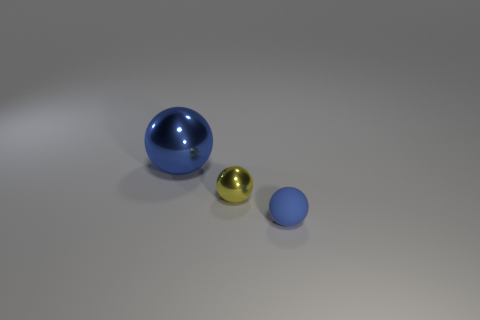Are there any other things that are the same size as the blue metallic object?
Give a very brief answer. No. There is a blue sphere that is right of the blue metallic object; is it the same size as the metal sphere that is right of the large metallic sphere?
Offer a very short reply. Yes. Is there anything else that is the same material as the big ball?
Offer a very short reply. Yes. What number of things are things that are left of the yellow metallic thing or blue things on the right side of the large shiny sphere?
Make the answer very short. 2. Is the material of the yellow object the same as the sphere on the left side of the tiny yellow shiny ball?
Offer a very short reply. Yes. The thing that is on the left side of the blue rubber sphere and in front of the blue metallic object has what shape?
Give a very brief answer. Sphere. What number of other things are there of the same color as the tiny matte thing?
Your answer should be very brief. 1. The small matte object is what shape?
Your response must be concise. Sphere. There is a tiny sphere that is left of the blue sphere that is in front of the large ball; what is its color?
Offer a terse response. Yellow. There is a rubber sphere; is it the same color as the small sphere behind the tiny blue matte thing?
Give a very brief answer. No. 